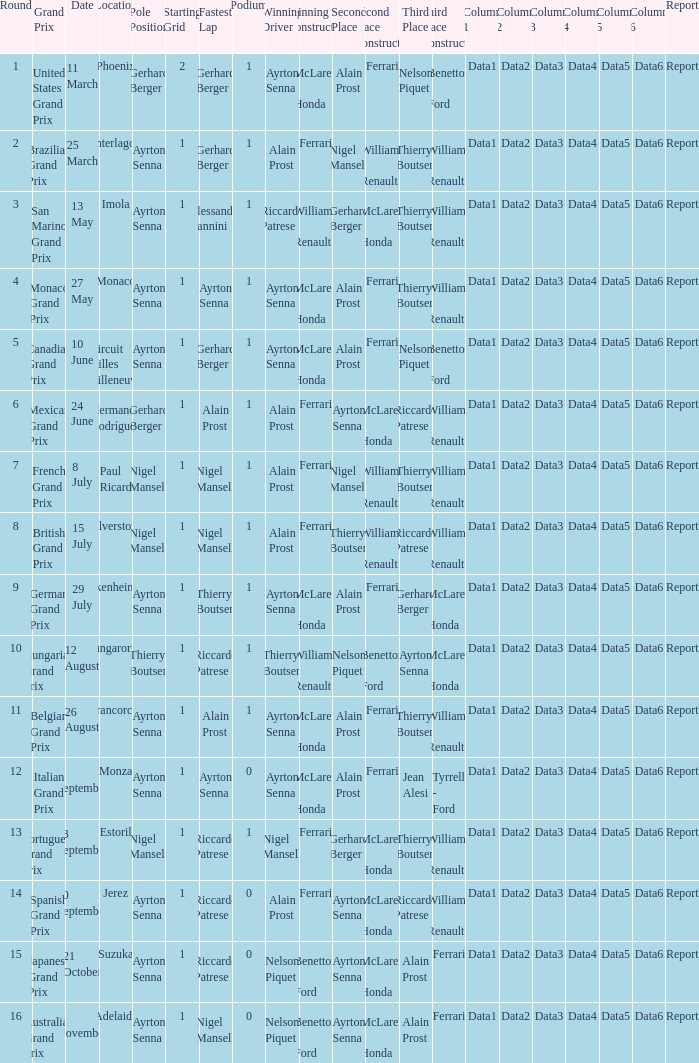What is the date that Ayrton Senna was the drive in Monza? 9 September. 